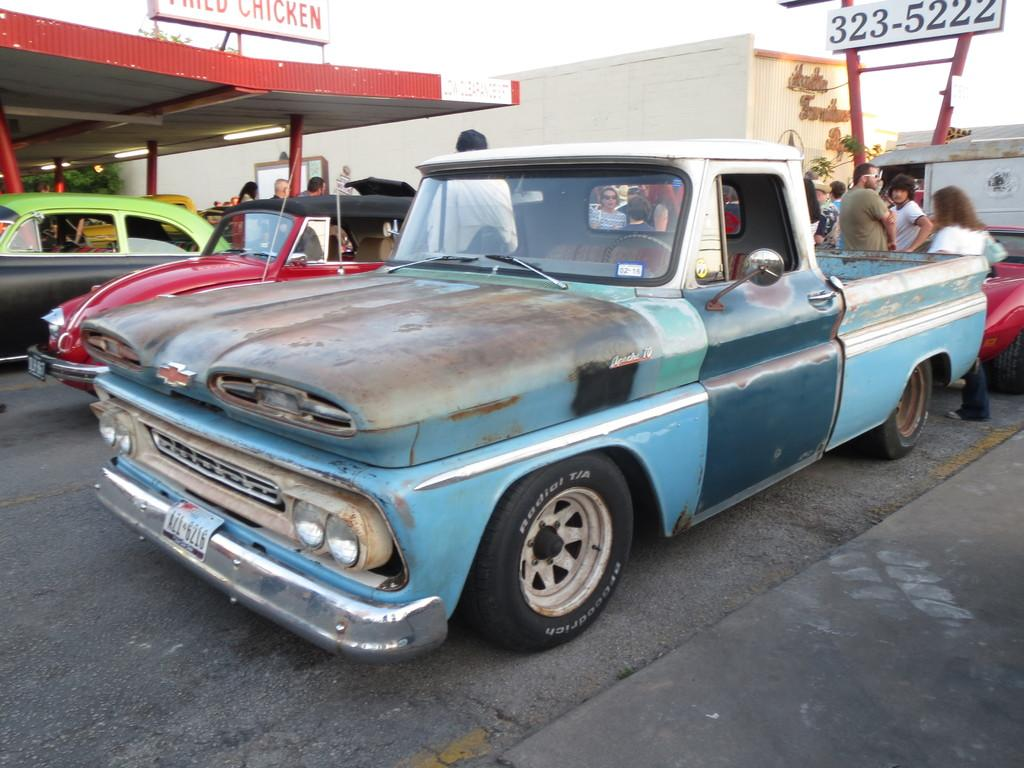What is the main subject in the center of the image? There is a car in the center of the image. Where is the car located? The car is on the road. What can be seen in the background of the image? There are persons, cars, poles, buildings, an advertisement, and the sky visible in the background. What type of calculator is being used by the brain in the image? There is no calculator or brain present in the image. 